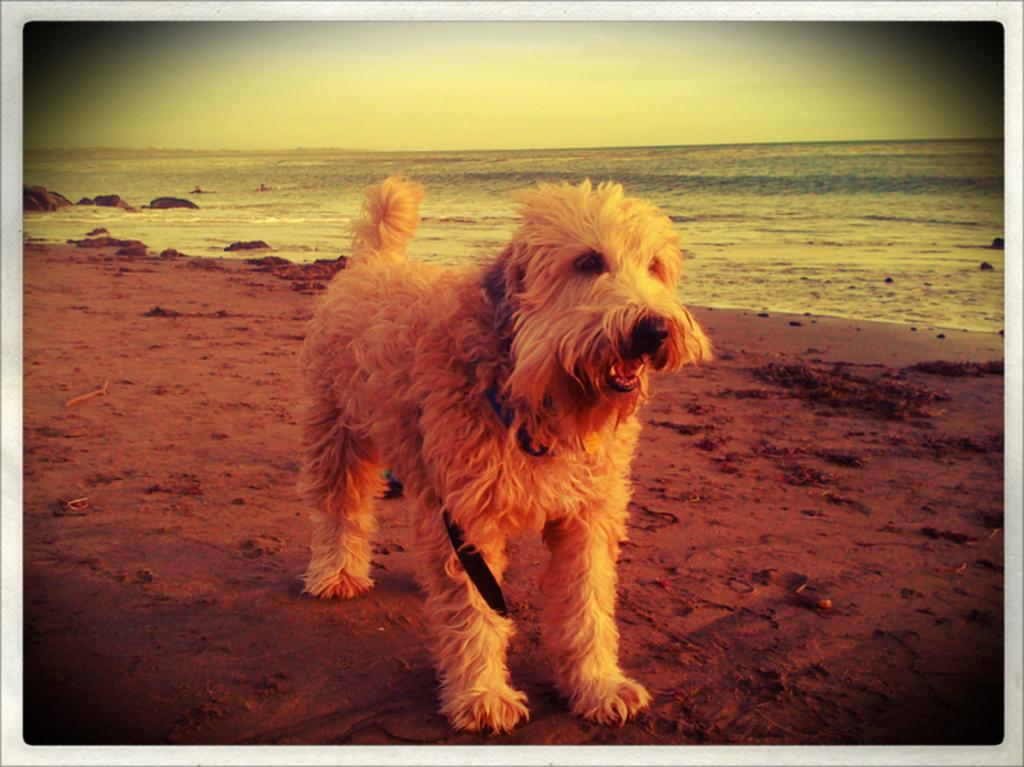What is the main subject in the center of the image? There is a dog in the center of the image. What is the condition of the floor where the dog is standing? The dog is on a muddy floor. What can be seen in the background of the image? There is water visible in the background of the image. What type of fork can be seen in the image? There is no fork present in the image. What is the air quality like in the image? The provided facts do not give information about the air quality in the image. 